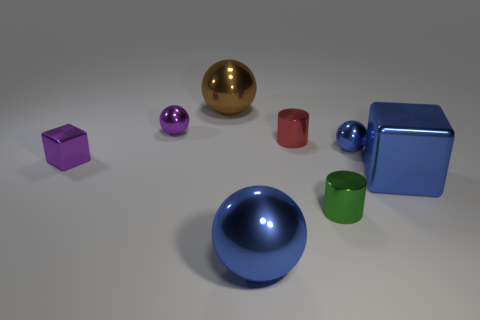Subtract 2 balls. How many balls are left? 2 Subtract all big brown balls. How many balls are left? 3 Subtract all purple spheres. How many spheres are left? 3 Add 1 red metallic objects. How many objects exist? 9 Subtract all cyan spheres. Subtract all gray cubes. How many spheres are left? 4 Subtract all blocks. How many objects are left? 6 Subtract all tiny metal things. Subtract all large brown spheres. How many objects are left? 2 Add 2 blue cubes. How many blue cubes are left? 3 Add 3 big spheres. How many big spheres exist? 5 Subtract 1 purple spheres. How many objects are left? 7 